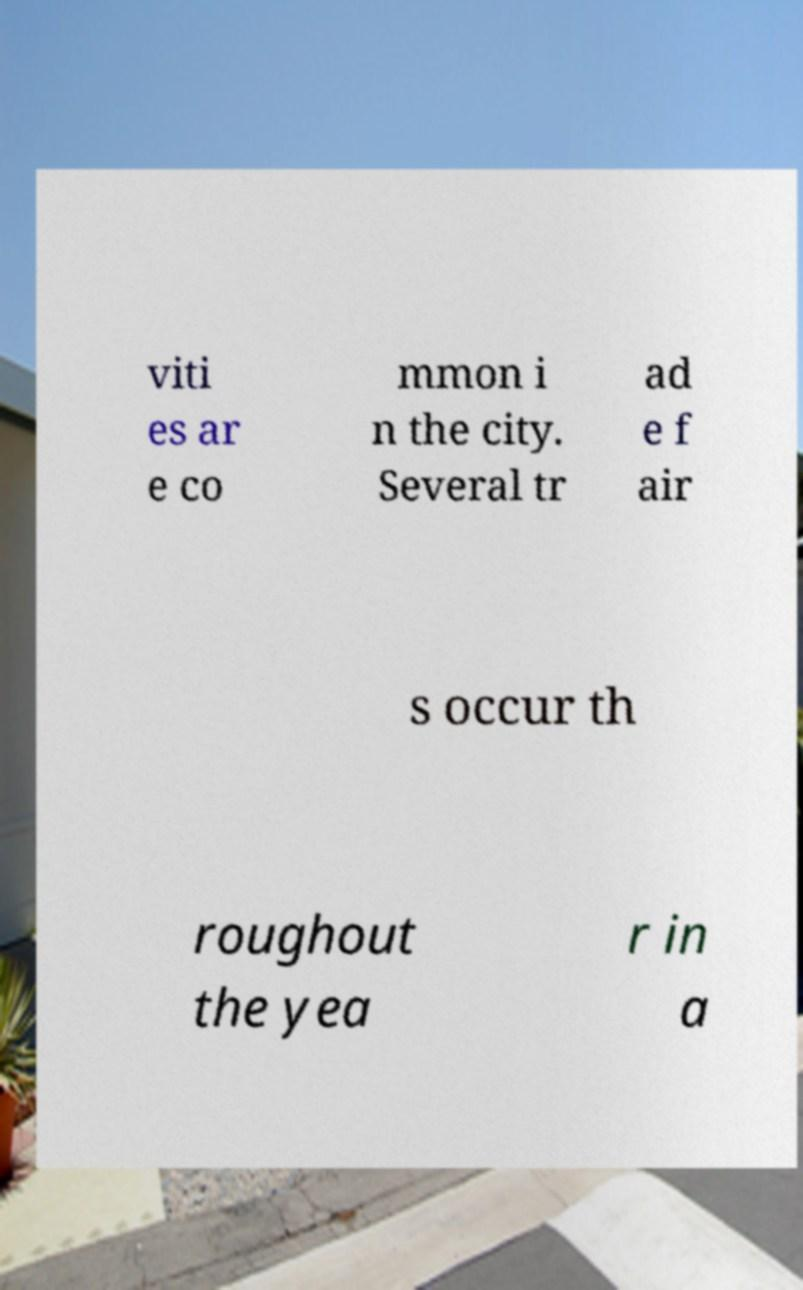Can you accurately transcribe the text from the provided image for me? viti es ar e co mmon i n the city. Several tr ad e f air s occur th roughout the yea r in a 